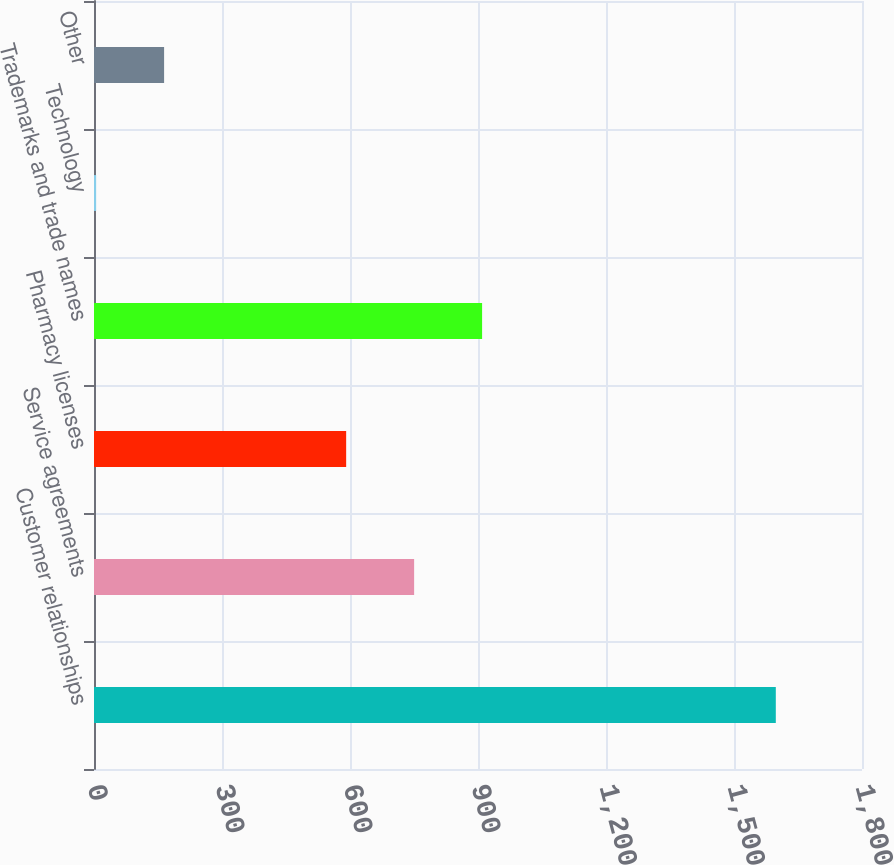<chart> <loc_0><loc_0><loc_500><loc_500><bar_chart><fcel>Customer relationships<fcel>Service agreements<fcel>Pharmacy licenses<fcel>Trademarks and trade names<fcel>Technology<fcel>Other<nl><fcel>1598<fcel>750.3<fcel>591<fcel>909.6<fcel>5<fcel>164.3<nl></chart> 